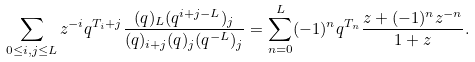<formula> <loc_0><loc_0><loc_500><loc_500>\sum _ { 0 \leq i , j \leq L } z ^ { - i } q ^ { T _ { i } + j } \frac { ( q ) _ { L } ( q ^ { i + j - L } ) _ { j } } { ( q ) _ { i + j } ( q ) _ { j } ( q ^ { - L } ) _ { j } } = \sum _ { n = 0 } ^ { L } ( - 1 ) ^ { n } q ^ { T _ { n } } \frac { z + ( - 1 ) ^ { n } z ^ { - n } } { 1 + z } .</formula> 